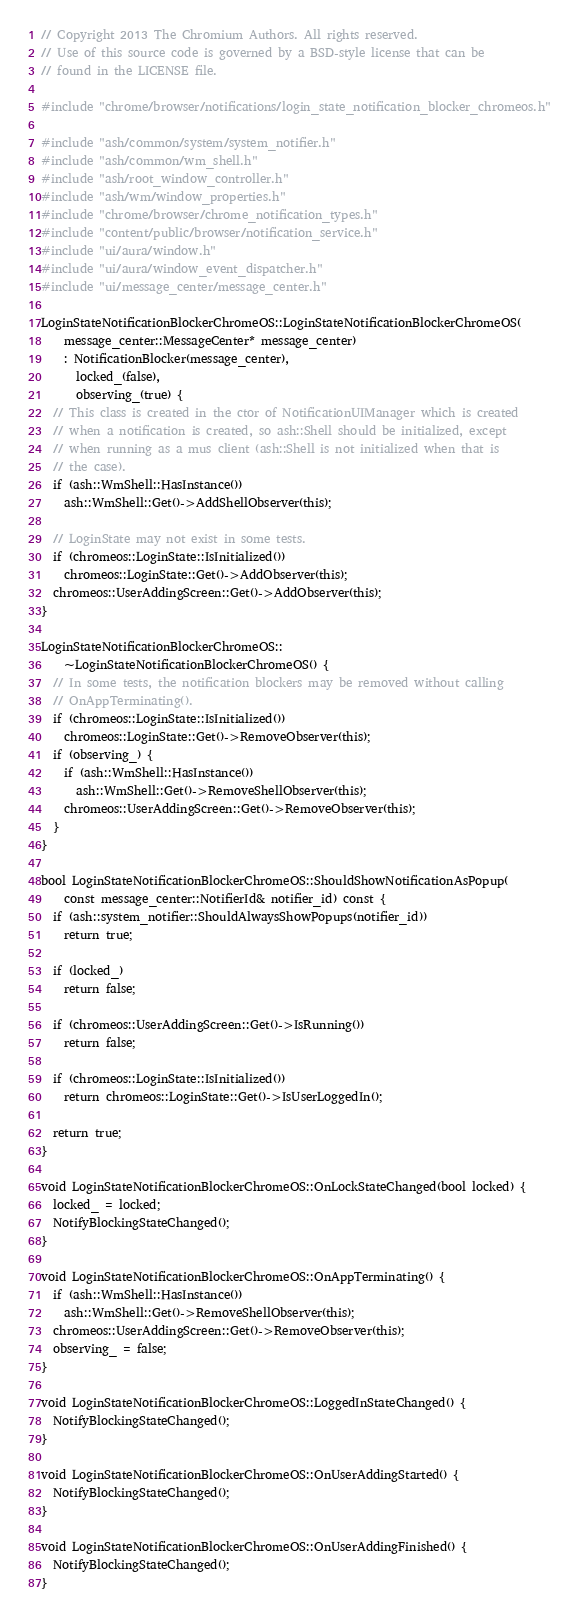<code> <loc_0><loc_0><loc_500><loc_500><_C++_>// Copyright 2013 The Chromium Authors. All rights reserved.
// Use of this source code is governed by a BSD-style license that can be
// found in the LICENSE file.

#include "chrome/browser/notifications/login_state_notification_blocker_chromeos.h"

#include "ash/common/system/system_notifier.h"
#include "ash/common/wm_shell.h"
#include "ash/root_window_controller.h"
#include "ash/wm/window_properties.h"
#include "chrome/browser/chrome_notification_types.h"
#include "content/public/browser/notification_service.h"
#include "ui/aura/window.h"
#include "ui/aura/window_event_dispatcher.h"
#include "ui/message_center/message_center.h"

LoginStateNotificationBlockerChromeOS::LoginStateNotificationBlockerChromeOS(
    message_center::MessageCenter* message_center)
    : NotificationBlocker(message_center),
      locked_(false),
      observing_(true) {
  // This class is created in the ctor of NotificationUIManager which is created
  // when a notification is created, so ash::Shell should be initialized, except
  // when running as a mus client (ash::Shell is not initialized when that is
  // the case).
  if (ash::WmShell::HasInstance())
    ash::WmShell::Get()->AddShellObserver(this);

  // LoginState may not exist in some tests.
  if (chromeos::LoginState::IsInitialized())
    chromeos::LoginState::Get()->AddObserver(this);
  chromeos::UserAddingScreen::Get()->AddObserver(this);
}

LoginStateNotificationBlockerChromeOS::
    ~LoginStateNotificationBlockerChromeOS() {
  // In some tests, the notification blockers may be removed without calling
  // OnAppTerminating().
  if (chromeos::LoginState::IsInitialized())
    chromeos::LoginState::Get()->RemoveObserver(this);
  if (observing_) {
    if (ash::WmShell::HasInstance())
      ash::WmShell::Get()->RemoveShellObserver(this);
    chromeos::UserAddingScreen::Get()->RemoveObserver(this);
  }
}

bool LoginStateNotificationBlockerChromeOS::ShouldShowNotificationAsPopup(
    const message_center::NotifierId& notifier_id) const {
  if (ash::system_notifier::ShouldAlwaysShowPopups(notifier_id))
    return true;

  if (locked_)
    return false;

  if (chromeos::UserAddingScreen::Get()->IsRunning())
    return false;

  if (chromeos::LoginState::IsInitialized())
    return chromeos::LoginState::Get()->IsUserLoggedIn();

  return true;
}

void LoginStateNotificationBlockerChromeOS::OnLockStateChanged(bool locked) {
  locked_ = locked;
  NotifyBlockingStateChanged();
}

void LoginStateNotificationBlockerChromeOS::OnAppTerminating() {
  if (ash::WmShell::HasInstance())
    ash::WmShell::Get()->RemoveShellObserver(this);
  chromeos::UserAddingScreen::Get()->RemoveObserver(this);
  observing_ = false;
}

void LoginStateNotificationBlockerChromeOS::LoggedInStateChanged() {
  NotifyBlockingStateChanged();
}

void LoginStateNotificationBlockerChromeOS::OnUserAddingStarted() {
  NotifyBlockingStateChanged();
}

void LoginStateNotificationBlockerChromeOS::OnUserAddingFinished() {
  NotifyBlockingStateChanged();
}
</code> 